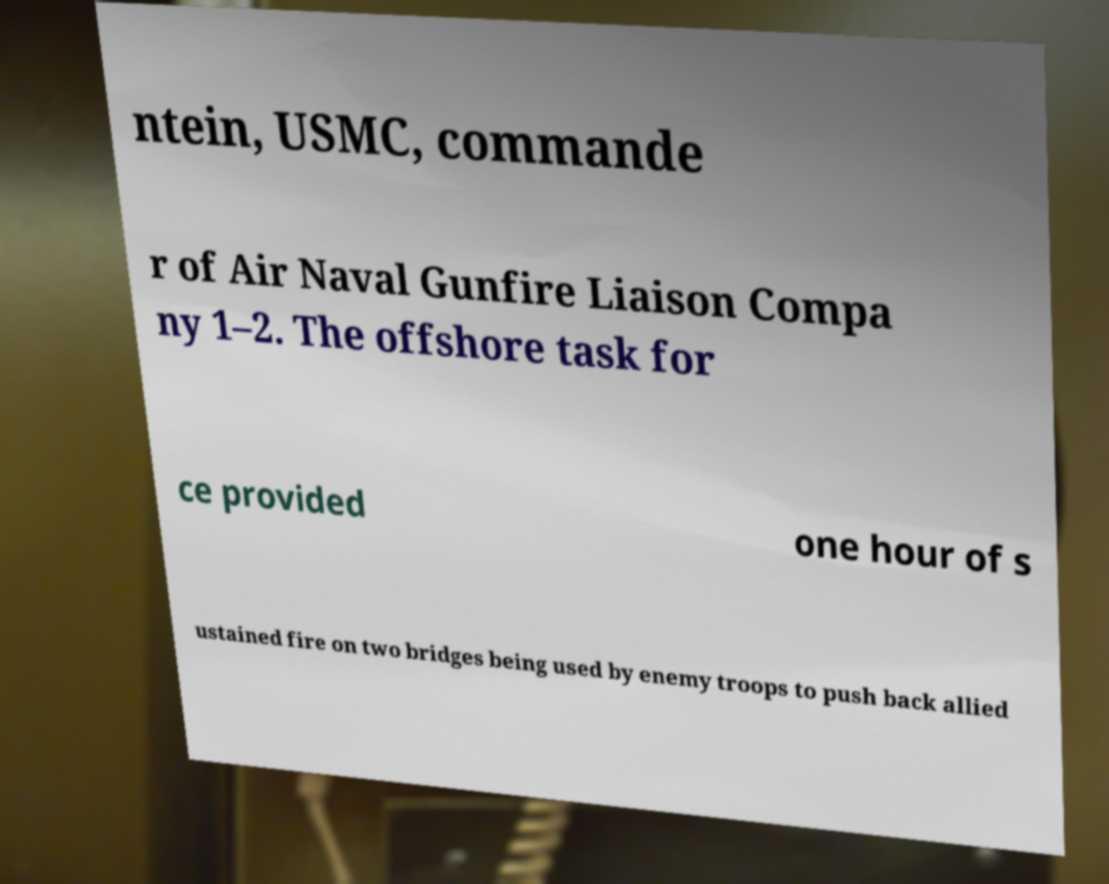Please read and relay the text visible in this image. What does it say? ntein, USMC, commande r of Air Naval Gunfire Liaison Compa ny 1–2. The offshore task for ce provided one hour of s ustained fire on two bridges being used by enemy troops to push back allied 